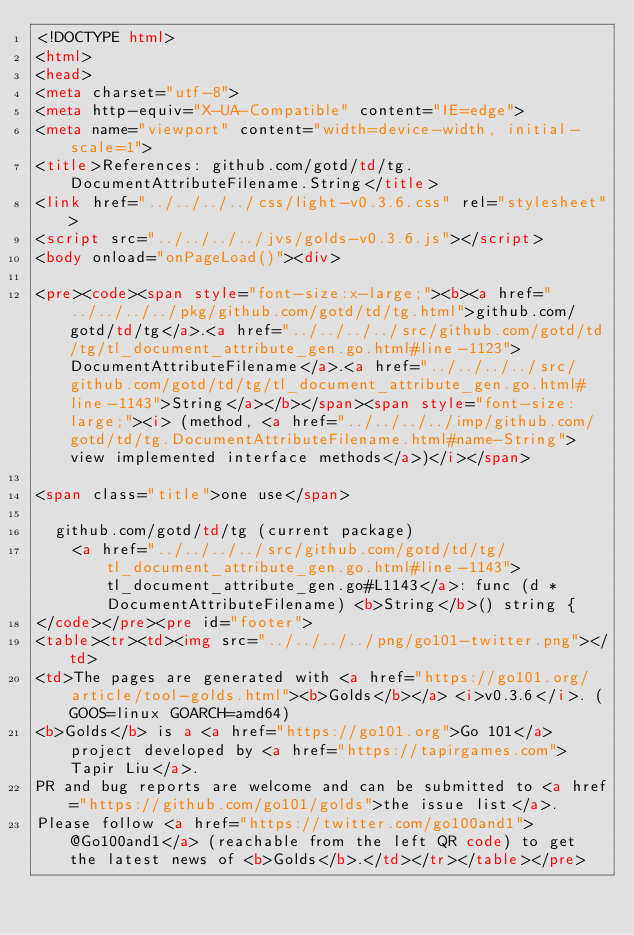Convert code to text. <code><loc_0><loc_0><loc_500><loc_500><_HTML_><!DOCTYPE html>
<html>
<head>
<meta charset="utf-8">
<meta http-equiv="X-UA-Compatible" content="IE=edge">
<meta name="viewport" content="width=device-width, initial-scale=1">
<title>References: github.com/gotd/td/tg.DocumentAttributeFilename.String</title>
<link href="../../../../css/light-v0.3.6.css" rel="stylesheet">
<script src="../../../../jvs/golds-v0.3.6.js"></script>
<body onload="onPageLoad()"><div>

<pre><code><span style="font-size:x-large;"><b><a href="../../../../pkg/github.com/gotd/td/tg.html">github.com/gotd/td/tg</a>.<a href="../../../../src/github.com/gotd/td/tg/tl_document_attribute_gen.go.html#line-1123">DocumentAttributeFilename</a>.<a href="../../../../src/github.com/gotd/td/tg/tl_document_attribute_gen.go.html#line-1143">String</a></b></span><span style="font-size: large;"><i> (method, <a href="../../../../imp/github.com/gotd/td/tg.DocumentAttributeFilename.html#name-String">view implemented interface methods</a>)</i></span>

<span class="title">one use</span>

	github.com/gotd/td/tg (current package)
		<a href="../../../../src/github.com/gotd/td/tg/tl_document_attribute_gen.go.html#line-1143">tl_document_attribute_gen.go#L1143</a>: func (d *DocumentAttributeFilename) <b>String</b>() string {
</code></pre><pre id="footer">
<table><tr><td><img src="../../../../png/go101-twitter.png"></td>
<td>The pages are generated with <a href="https://go101.org/article/tool-golds.html"><b>Golds</b></a> <i>v0.3.6</i>. (GOOS=linux GOARCH=amd64)
<b>Golds</b> is a <a href="https://go101.org">Go 101</a> project developed by <a href="https://tapirgames.com">Tapir Liu</a>.
PR and bug reports are welcome and can be submitted to <a href="https://github.com/go101/golds">the issue list</a>.
Please follow <a href="https://twitter.com/go100and1">@Go100and1</a> (reachable from the left QR code) to get the latest news of <b>Golds</b>.</td></tr></table></pre></code> 